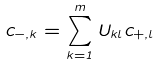<formula> <loc_0><loc_0><loc_500><loc_500>c _ { - , k } = \sum _ { k = 1 } ^ { m } U _ { k l } c _ { + , l }</formula> 